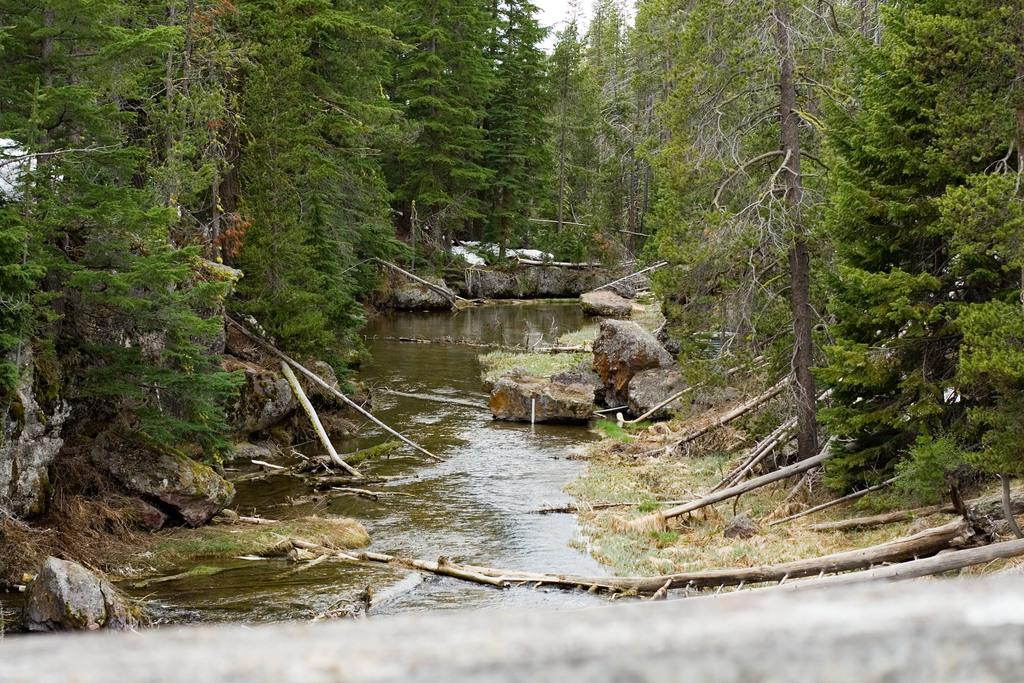What is located in the middle of the image? There is water and trees in the middle of the image. Can you describe the water in the image? The water is visible in the middle of the image. What type of vegetation is present in the image? There are trees in the middle of the image. What type of scarecrow can be seen standing in the water in the image? There is no scarecrow present in the image; it features water and trees. What company is responsible for the water in the image? The image does not provide information about the company responsible for the water. 